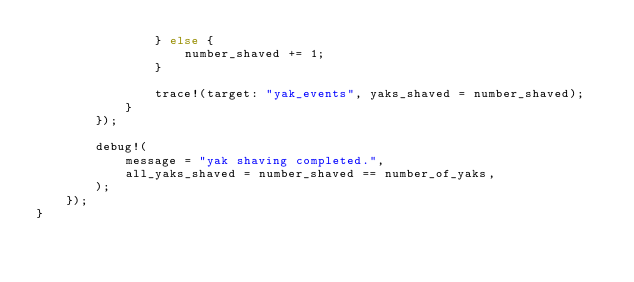<code> <loc_0><loc_0><loc_500><loc_500><_Rust_>                } else {
                    number_shaved += 1;
                }

                trace!(target: "yak_events", yaks_shaved = number_shaved);
            }
        });

        debug!(
            message = "yak shaving completed.",
            all_yaks_shaved = number_shaved == number_of_yaks,
        );
    });
}
</code> 